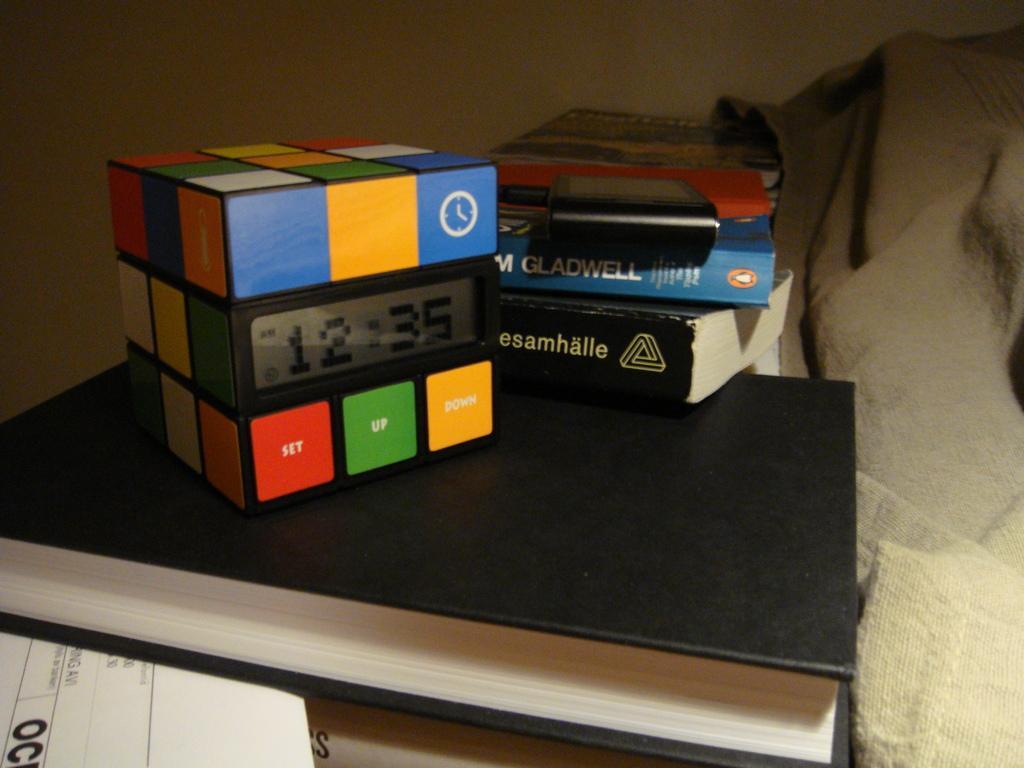Please provide a concise description of this image. This picture is clicked inside the room. In this picture, we see books, paper and a Rubik's cube. Behind that, we see a wall in white color. On the right side of the picture, we see a grey color sheet. 